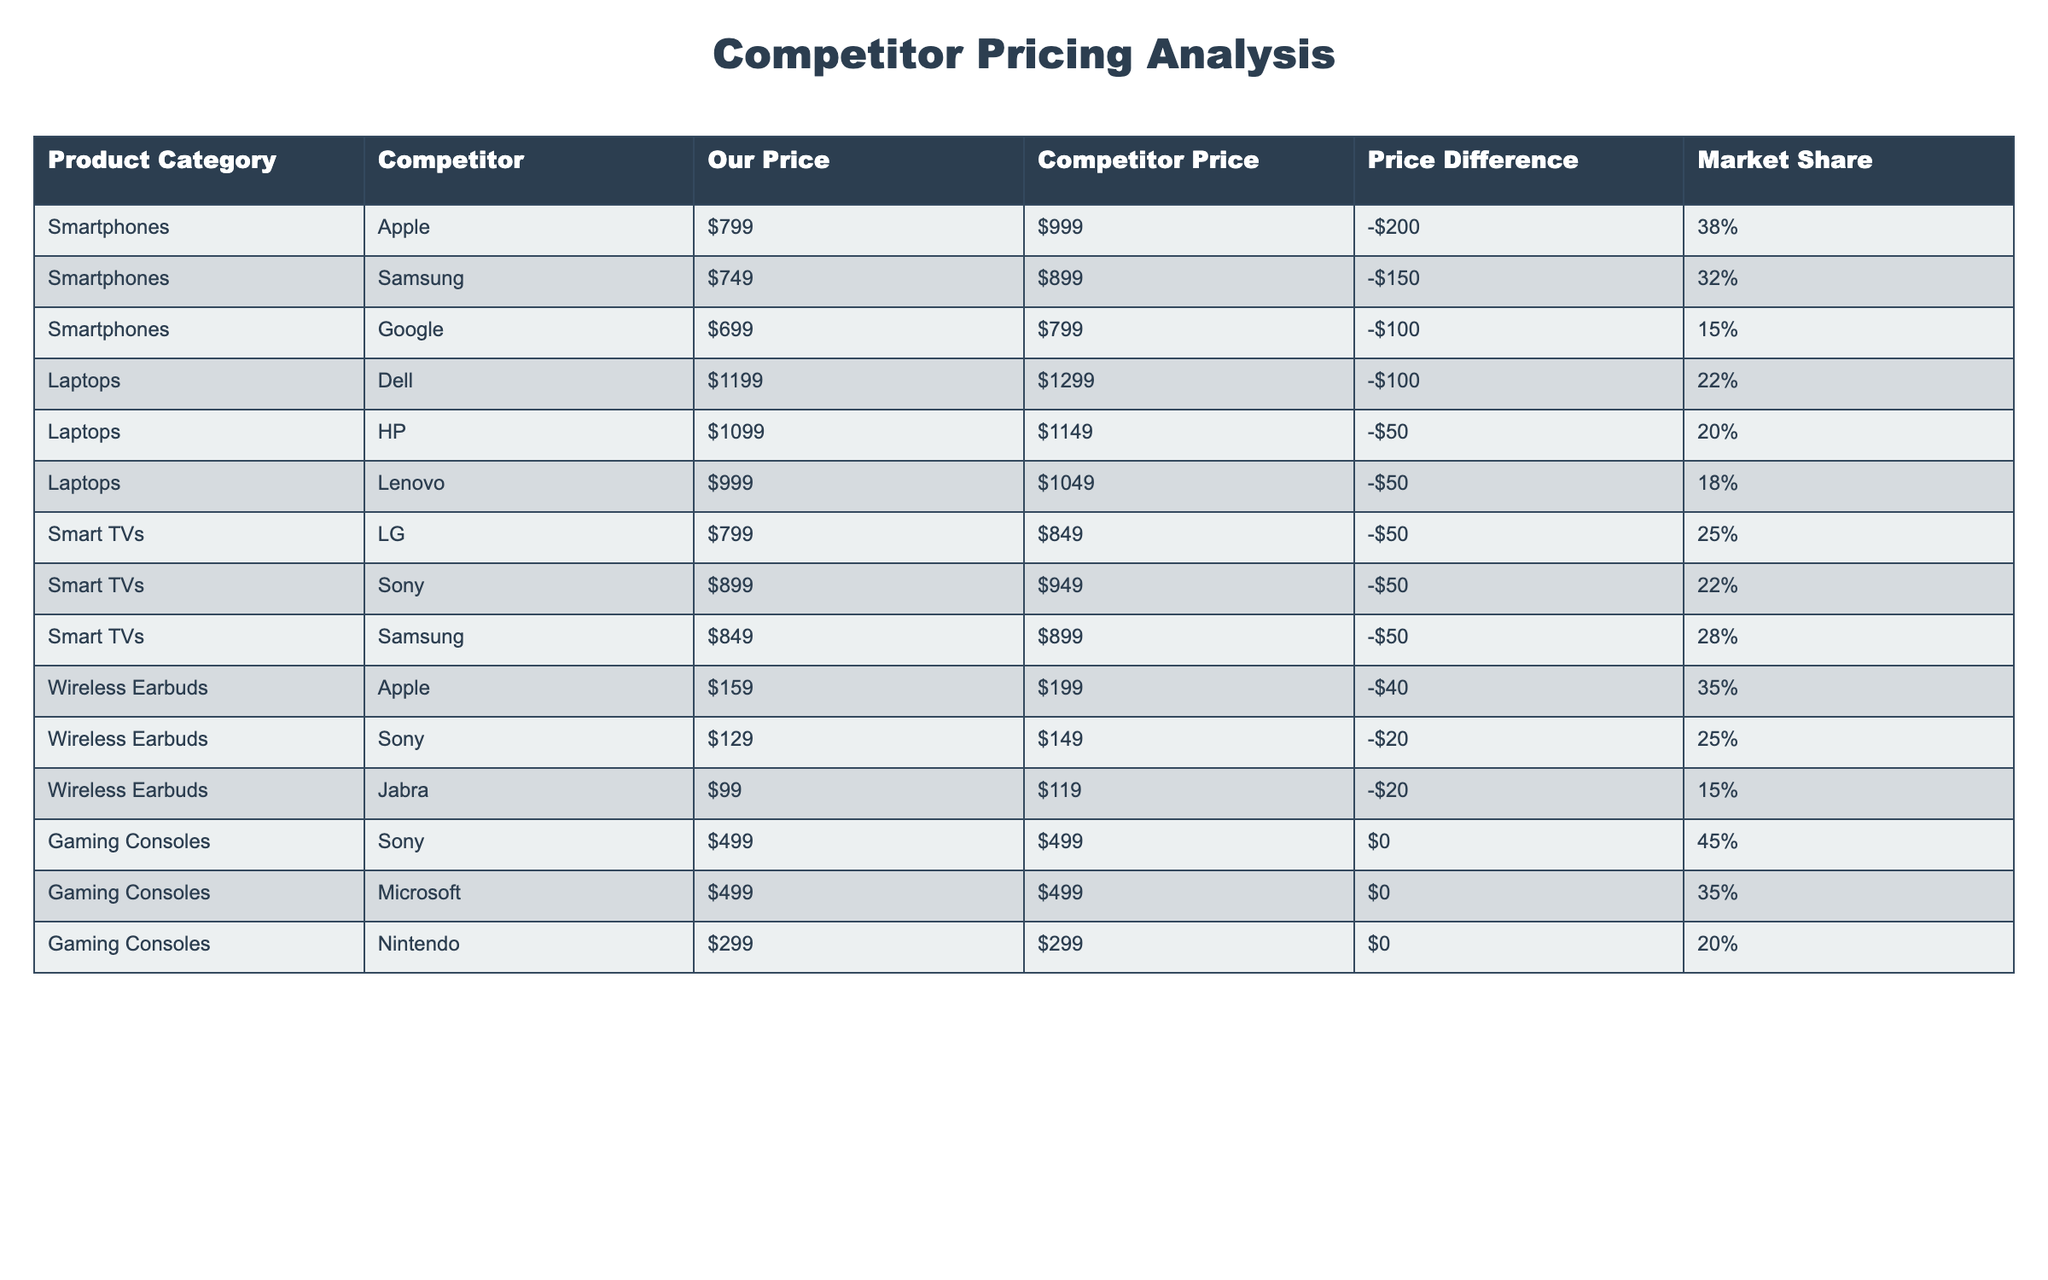What is the price difference between our smartphones and Google's smartphones? Our price for smartphones is $699 and Google's price is $799. To find the price difference, we subtract our price from Google's price: $699 - $799 = -$100. This indicates we are $100 cheaper than Google.
Answer: -$100 Which competitor has the highest market share in the smartphone category? According to the table, Apple has a market share of 38%, Samsung has 32%, and Google has 15%. The highest among these is Apple with 38%.
Answer: Apple Are our prices lower than the competitors for all categories listed? By analyzing the table, our prices are lower than the competitors for all categories besides gaming consoles, where the prices are the same ($499). So for all categories except gaming consoles, our prices are lower.
Answer: No What is the average price difference for laptops between our prices and competitors? We have three competitors in the laptop category: Dell ($100), HP ($50), and Lenovo ($50). Summing these price differences gives us $100 + $50 + $50 = $200. We then divide by the number of competitors (3): $200 / 3 = $66.67.
Answer: $66.67 Is there any category where our prices match the competitors'? Reviewing the table shows that in the gaming consoles category, our price matches with all competitors (Sony, Microsoft, and Nintendo), each at $499. Thus, there are categories with matching prices.
Answer: Yes 